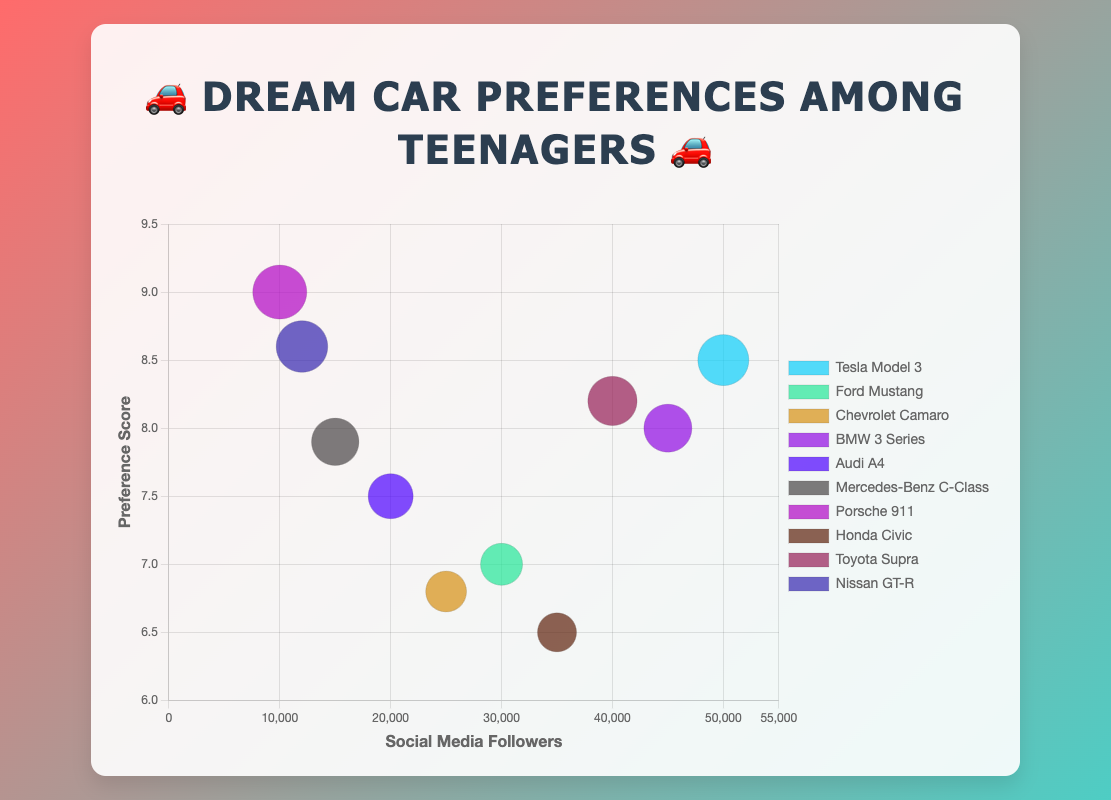What's the title of the chart? The title is usually found at the top of the chart and it summarizes what the chart is about. In this case, the title is displayed in large text above the main plot area.
Answer: 🚗 Dream Car Preferences Among Teenagers 🚗 What are the x-axis and y-axis representing? The x-axis represents the 'Social Media Followers', and the y-axis represents the 'Preference Score'. These labels are indicated next to the respective axes.
Answer: Social Media Followers, Preference Score Which car has the highest preference score? Locate the bubble that is the highest on the y-axis, which measures preference score. The car in that position has the highest score.
Answer: Porsche 911 How many cars have a preference score above 8.0? Count the number of bubbles that are situated above the 8.0 mark on the y-axis. Each bubble represents a car. There are five such bubbles in the chart.
Answer: 5 Which car has the most social media followers? Locate the bubble that is furthest to the right on the x-axis, as this axis represents the number of followers. This will be the bubble for the car with the most followers.
Answer: Tesla Model 3 Compare the preference score of the Audi A4 and Mercedes-Benz C-Class. Which one is higher? Find the bubbles for Audi A4 and Mercedes-Benz C-Class. The Audi A4 bubble shows a score of 7.5, whereas the Mercedes-Benz C-Class bubble shows a score of 7.9. Therefore, Mercedes-Benz C-Class has a higher score.
Answer: Mercedes-Benz C-Class What is the total number of social media followers for Ford Mustang and Honda Civic combined? Find the number of followers for both cars from the chart: Ford Mustang has 30,000 followers, and Honda Civic has 35,000 followers. Adding these together gives 30,000 + 35,000 = 65,000.
Answer: 65,000 Which car among the ones with a preference score below 7.0 has the most followers? Identify the bubbles below the 7.0 y-axis mark. Among these, find the bubble furthest to the right (highest x-axis value). This is the bubble for the Ford Mustang, which has 30,000 followers.
Answer: Ford Mustang What is the average preference score for Tesla Model 3, BMW 3 Series, and Toyota Supra? Locate the bubbles for these three cars and note their preference scores: Tesla Model 3 (8.5), BMW 3 Series (8.0), and Toyota Supra (8.2). Calculate the average by adding these scores and dividing by three: (8.5 + 8.0 + 8.2) / 3 = 8.233.
Answer: 8.23 Between Nissan GT-R and Porsche 911, which car has fewer social media followers? Locate the bubbles for Nissan GT-R and Porsche 911, and check their follower counts. The Nissan GT-R has 12,000 followers, while the Porsche 911 has 10,000 followers. Hence, Porsche 911 has fewer followers.
Answer: Porsche 911 